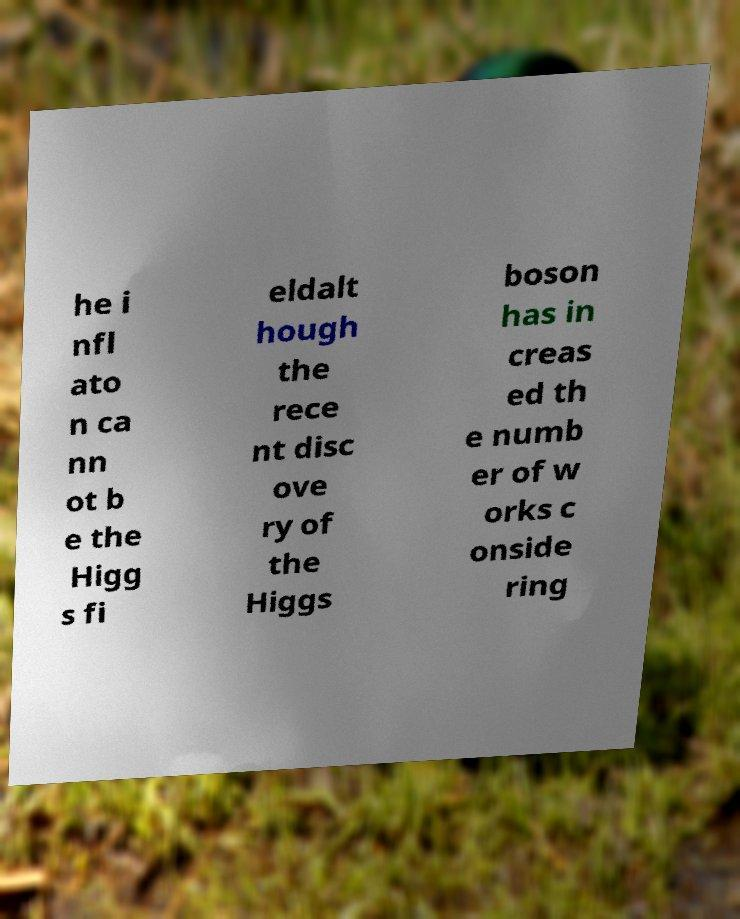Please identify and transcribe the text found in this image. he i nfl ato n ca nn ot b e the Higg s fi eldalt hough the rece nt disc ove ry of the Higgs boson has in creas ed th e numb er of w orks c onside ring 